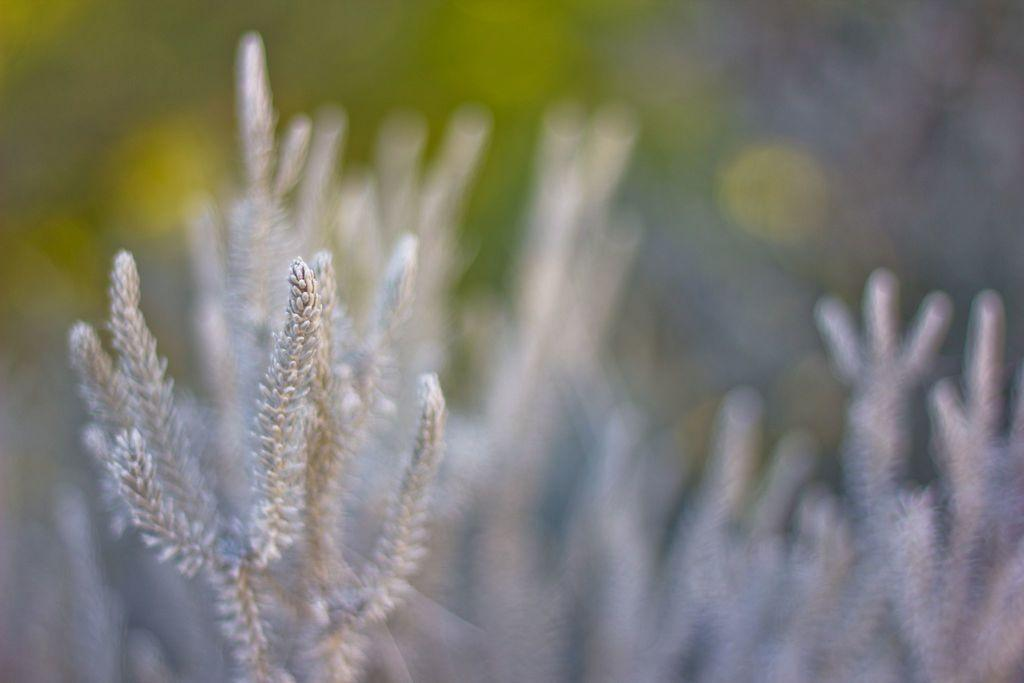What type of living organisms can be seen in the image? Plants can be seen in the image. Can you describe the background of the image? The background of the image is blurry. How many control panels are visible in the image? There are no control panels present in the image; it features plants and a blurry background. 